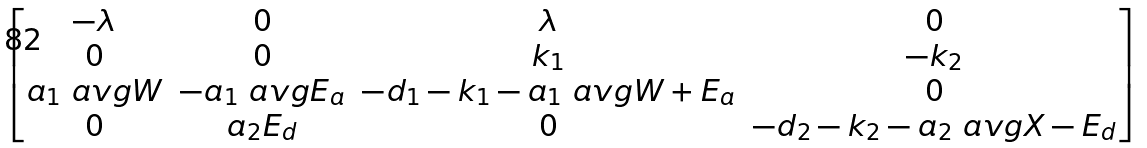<formula> <loc_0><loc_0><loc_500><loc_500>\begin{bmatrix} - \lambda & 0 & \lambda & 0 \\ 0 & 0 & k _ { 1 } & - k _ { 2 } \\ a _ { 1 } \ a v g { W } & - a _ { 1 } \ a v g { E _ { a } } & - d _ { 1 } - k _ { 1 } - a _ { 1 } \ a v g { W + E _ { a } } & 0 \\ 0 & a _ { 2 } E _ { d } & 0 & - d _ { 2 } - k _ { 2 } - a _ { 2 } \ a v g { X - E _ { d } } \end{bmatrix}</formula> 